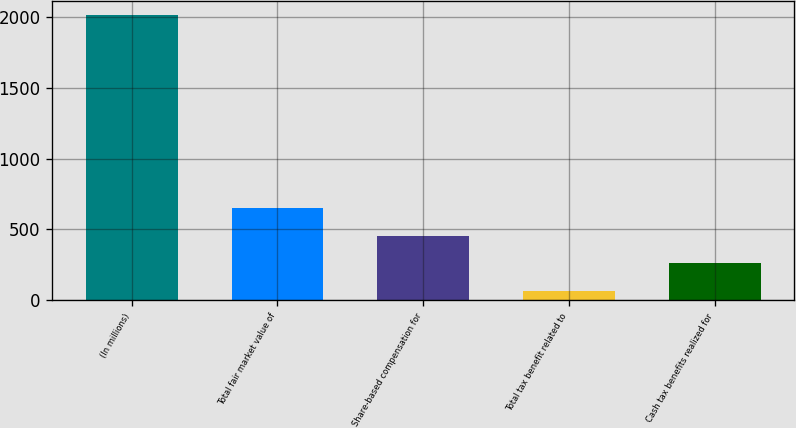Convert chart to OTSL. <chart><loc_0><loc_0><loc_500><loc_500><bar_chart><fcel>(In millions)<fcel>Total fair market value of<fcel>Share-based compensation for<fcel>Total tax benefit related to<fcel>Cash tax benefits realized for<nl><fcel>2015<fcel>649.3<fcel>454.2<fcel>64<fcel>259.1<nl></chart> 